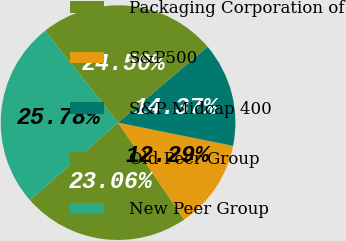<chart> <loc_0><loc_0><loc_500><loc_500><pie_chart><fcel>Packaging Corporation of<fcel>S&P500<fcel>S&P Midcap 400<fcel>Old Peer Group<fcel>New Peer Group<nl><fcel>23.06%<fcel>12.29%<fcel>14.37%<fcel>24.5%<fcel>25.78%<nl></chart> 